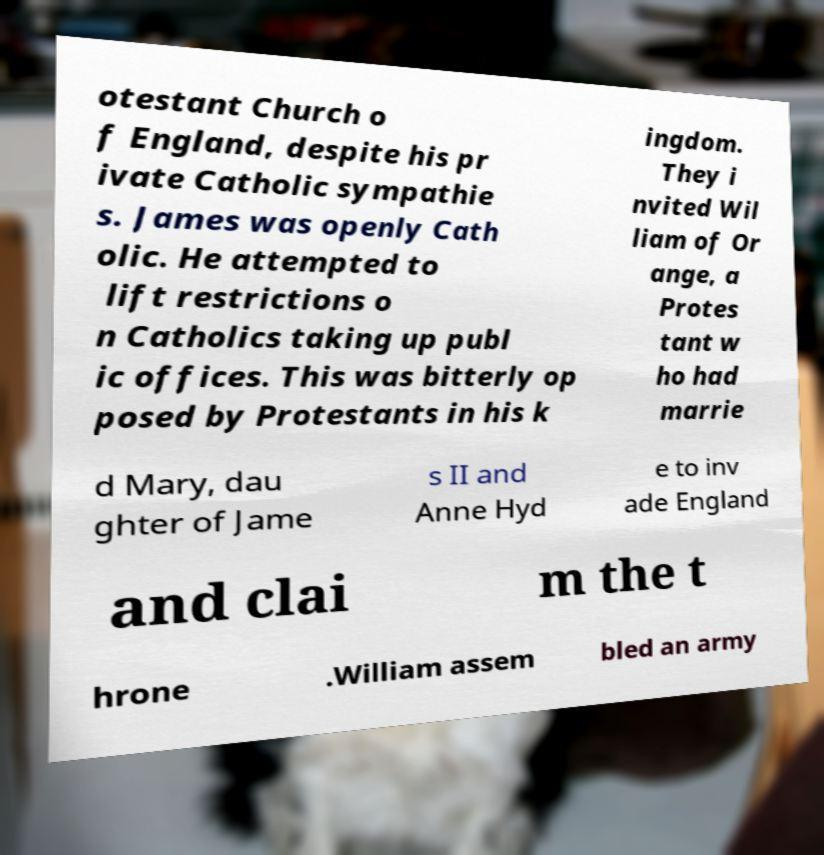Please identify and transcribe the text found in this image. otestant Church o f England, despite his pr ivate Catholic sympathie s. James was openly Cath olic. He attempted to lift restrictions o n Catholics taking up publ ic offices. This was bitterly op posed by Protestants in his k ingdom. They i nvited Wil liam of Or ange, a Protes tant w ho had marrie d Mary, dau ghter of Jame s II and Anne Hyd e to inv ade England and clai m the t hrone .William assem bled an army 